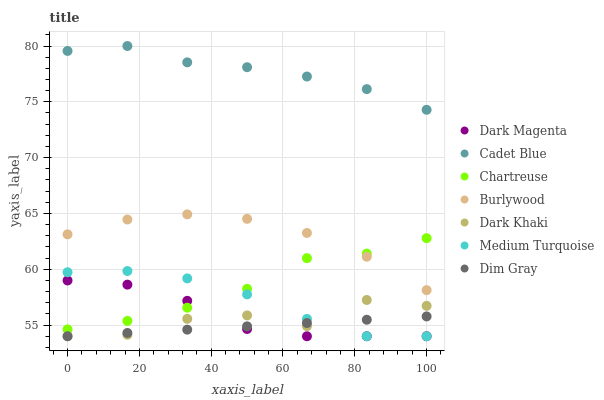Does Dim Gray have the minimum area under the curve?
Answer yes or no. Yes. Does Cadet Blue have the maximum area under the curve?
Answer yes or no. Yes. Does Dark Magenta have the minimum area under the curve?
Answer yes or no. No. Does Dark Magenta have the maximum area under the curve?
Answer yes or no. No. Is Dim Gray the smoothest?
Answer yes or no. Yes. Is Dark Khaki the roughest?
Answer yes or no. Yes. Is Dark Magenta the smoothest?
Answer yes or no. No. Is Dark Magenta the roughest?
Answer yes or no. No. Does Dark Magenta have the lowest value?
Answer yes or no. Yes. Does Burlywood have the lowest value?
Answer yes or no. No. Does Cadet Blue have the highest value?
Answer yes or no. Yes. Does Dark Magenta have the highest value?
Answer yes or no. No. Is Burlywood less than Cadet Blue?
Answer yes or no. Yes. Is Cadet Blue greater than Dark Khaki?
Answer yes or no. Yes. Does Burlywood intersect Chartreuse?
Answer yes or no. Yes. Is Burlywood less than Chartreuse?
Answer yes or no. No. Is Burlywood greater than Chartreuse?
Answer yes or no. No. Does Burlywood intersect Cadet Blue?
Answer yes or no. No. 